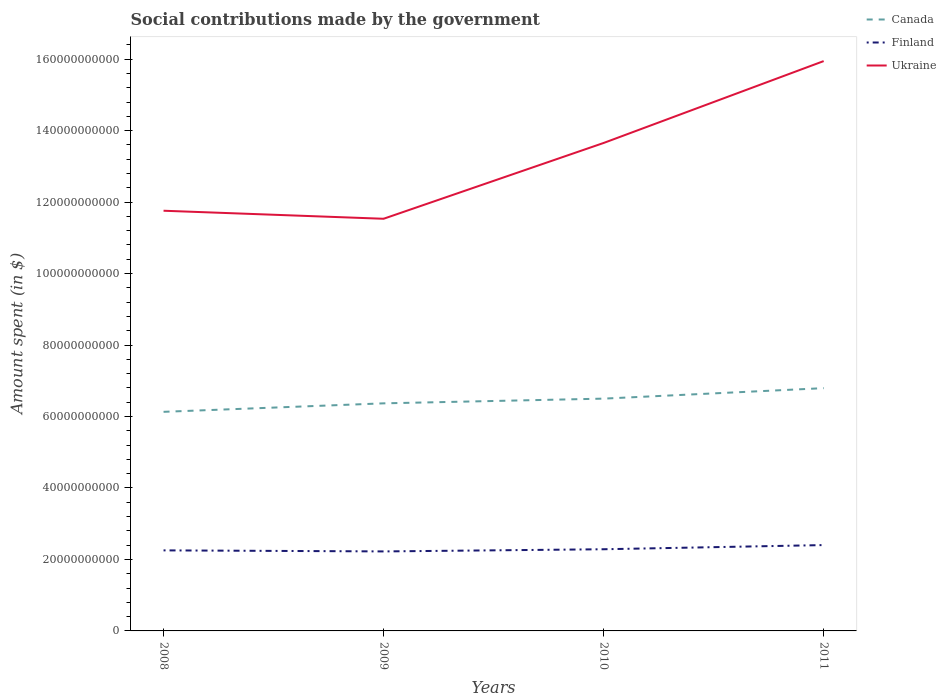How many different coloured lines are there?
Offer a terse response. 3. Does the line corresponding to Finland intersect with the line corresponding to Canada?
Provide a short and direct response. No. Across all years, what is the maximum amount spent on social contributions in Canada?
Make the answer very short. 6.13e+1. What is the total amount spent on social contributions in Finland in the graph?
Offer a very short reply. -3.15e+08. What is the difference between the highest and the second highest amount spent on social contributions in Finland?
Keep it short and to the point. 1.78e+09. How many legend labels are there?
Offer a terse response. 3. What is the title of the graph?
Your answer should be very brief. Social contributions made by the government. What is the label or title of the Y-axis?
Offer a terse response. Amount spent (in $). What is the Amount spent (in $) of Canada in 2008?
Provide a succinct answer. 6.13e+1. What is the Amount spent (in $) in Finland in 2008?
Provide a short and direct response. 2.25e+1. What is the Amount spent (in $) of Ukraine in 2008?
Your response must be concise. 1.18e+11. What is the Amount spent (in $) in Canada in 2009?
Provide a short and direct response. 6.37e+1. What is the Amount spent (in $) in Finland in 2009?
Give a very brief answer. 2.22e+1. What is the Amount spent (in $) in Ukraine in 2009?
Keep it short and to the point. 1.15e+11. What is the Amount spent (in $) in Canada in 2010?
Your answer should be very brief. 6.50e+1. What is the Amount spent (in $) of Finland in 2010?
Offer a terse response. 2.29e+1. What is the Amount spent (in $) of Ukraine in 2010?
Your answer should be very brief. 1.37e+11. What is the Amount spent (in $) in Canada in 2011?
Provide a succinct answer. 6.79e+1. What is the Amount spent (in $) of Finland in 2011?
Ensure brevity in your answer.  2.40e+1. What is the Amount spent (in $) of Ukraine in 2011?
Offer a very short reply. 1.59e+11. Across all years, what is the maximum Amount spent (in $) in Canada?
Give a very brief answer. 6.79e+1. Across all years, what is the maximum Amount spent (in $) of Finland?
Offer a terse response. 2.40e+1. Across all years, what is the maximum Amount spent (in $) of Ukraine?
Keep it short and to the point. 1.59e+11. Across all years, what is the minimum Amount spent (in $) in Canada?
Give a very brief answer. 6.13e+1. Across all years, what is the minimum Amount spent (in $) of Finland?
Your answer should be very brief. 2.22e+1. Across all years, what is the minimum Amount spent (in $) of Ukraine?
Ensure brevity in your answer.  1.15e+11. What is the total Amount spent (in $) in Canada in the graph?
Offer a terse response. 2.58e+11. What is the total Amount spent (in $) of Finland in the graph?
Provide a succinct answer. 9.17e+1. What is the total Amount spent (in $) of Ukraine in the graph?
Provide a succinct answer. 5.29e+11. What is the difference between the Amount spent (in $) in Canada in 2008 and that in 2009?
Your response must be concise. -2.37e+09. What is the difference between the Amount spent (in $) of Finland in 2008 and that in 2009?
Give a very brief answer. 2.94e+08. What is the difference between the Amount spent (in $) of Ukraine in 2008 and that in 2009?
Keep it short and to the point. 2.25e+09. What is the difference between the Amount spent (in $) of Canada in 2008 and that in 2010?
Your answer should be compact. -3.69e+09. What is the difference between the Amount spent (in $) in Finland in 2008 and that in 2010?
Your answer should be very brief. -3.15e+08. What is the difference between the Amount spent (in $) in Ukraine in 2008 and that in 2010?
Offer a terse response. -1.90e+1. What is the difference between the Amount spent (in $) of Canada in 2008 and that in 2011?
Keep it short and to the point. -6.63e+09. What is the difference between the Amount spent (in $) of Finland in 2008 and that in 2011?
Offer a terse response. -1.48e+09. What is the difference between the Amount spent (in $) of Ukraine in 2008 and that in 2011?
Keep it short and to the point. -4.19e+1. What is the difference between the Amount spent (in $) of Canada in 2009 and that in 2010?
Your answer should be compact. -1.32e+09. What is the difference between the Amount spent (in $) of Finland in 2009 and that in 2010?
Provide a succinct answer. -6.09e+08. What is the difference between the Amount spent (in $) in Ukraine in 2009 and that in 2010?
Provide a succinct answer. -2.12e+1. What is the difference between the Amount spent (in $) of Canada in 2009 and that in 2011?
Offer a terse response. -4.25e+09. What is the difference between the Amount spent (in $) in Finland in 2009 and that in 2011?
Your answer should be very brief. -1.78e+09. What is the difference between the Amount spent (in $) of Ukraine in 2009 and that in 2011?
Offer a terse response. -4.41e+1. What is the difference between the Amount spent (in $) in Canada in 2010 and that in 2011?
Your answer should be compact. -2.93e+09. What is the difference between the Amount spent (in $) in Finland in 2010 and that in 2011?
Your response must be concise. -1.17e+09. What is the difference between the Amount spent (in $) of Ukraine in 2010 and that in 2011?
Make the answer very short. -2.29e+1. What is the difference between the Amount spent (in $) in Canada in 2008 and the Amount spent (in $) in Finland in 2009?
Make the answer very short. 3.91e+1. What is the difference between the Amount spent (in $) of Canada in 2008 and the Amount spent (in $) of Ukraine in 2009?
Your response must be concise. -5.40e+1. What is the difference between the Amount spent (in $) of Finland in 2008 and the Amount spent (in $) of Ukraine in 2009?
Offer a very short reply. -9.28e+1. What is the difference between the Amount spent (in $) in Canada in 2008 and the Amount spent (in $) in Finland in 2010?
Make the answer very short. 3.85e+1. What is the difference between the Amount spent (in $) of Canada in 2008 and the Amount spent (in $) of Ukraine in 2010?
Keep it short and to the point. -7.52e+1. What is the difference between the Amount spent (in $) of Finland in 2008 and the Amount spent (in $) of Ukraine in 2010?
Offer a very short reply. -1.14e+11. What is the difference between the Amount spent (in $) in Canada in 2008 and the Amount spent (in $) in Finland in 2011?
Offer a very short reply. 3.73e+1. What is the difference between the Amount spent (in $) in Canada in 2008 and the Amount spent (in $) in Ukraine in 2011?
Provide a succinct answer. -9.81e+1. What is the difference between the Amount spent (in $) in Finland in 2008 and the Amount spent (in $) in Ukraine in 2011?
Your answer should be compact. -1.37e+11. What is the difference between the Amount spent (in $) in Canada in 2009 and the Amount spent (in $) in Finland in 2010?
Keep it short and to the point. 4.08e+1. What is the difference between the Amount spent (in $) of Canada in 2009 and the Amount spent (in $) of Ukraine in 2010?
Your response must be concise. -7.29e+1. What is the difference between the Amount spent (in $) in Finland in 2009 and the Amount spent (in $) in Ukraine in 2010?
Offer a terse response. -1.14e+11. What is the difference between the Amount spent (in $) in Canada in 2009 and the Amount spent (in $) in Finland in 2011?
Offer a very short reply. 3.97e+1. What is the difference between the Amount spent (in $) of Canada in 2009 and the Amount spent (in $) of Ukraine in 2011?
Provide a short and direct response. -9.58e+1. What is the difference between the Amount spent (in $) in Finland in 2009 and the Amount spent (in $) in Ukraine in 2011?
Ensure brevity in your answer.  -1.37e+11. What is the difference between the Amount spent (in $) of Canada in 2010 and the Amount spent (in $) of Finland in 2011?
Your answer should be very brief. 4.10e+1. What is the difference between the Amount spent (in $) in Canada in 2010 and the Amount spent (in $) in Ukraine in 2011?
Provide a succinct answer. -9.45e+1. What is the difference between the Amount spent (in $) of Finland in 2010 and the Amount spent (in $) of Ukraine in 2011?
Provide a succinct answer. -1.37e+11. What is the average Amount spent (in $) in Canada per year?
Offer a very short reply. 6.45e+1. What is the average Amount spent (in $) in Finland per year?
Offer a very short reply. 2.29e+1. What is the average Amount spent (in $) of Ukraine per year?
Make the answer very short. 1.32e+11. In the year 2008, what is the difference between the Amount spent (in $) of Canada and Amount spent (in $) of Finland?
Provide a succinct answer. 3.88e+1. In the year 2008, what is the difference between the Amount spent (in $) in Canada and Amount spent (in $) in Ukraine?
Keep it short and to the point. -5.63e+1. In the year 2008, what is the difference between the Amount spent (in $) in Finland and Amount spent (in $) in Ukraine?
Make the answer very short. -9.50e+1. In the year 2009, what is the difference between the Amount spent (in $) in Canada and Amount spent (in $) in Finland?
Ensure brevity in your answer.  4.14e+1. In the year 2009, what is the difference between the Amount spent (in $) in Canada and Amount spent (in $) in Ukraine?
Your response must be concise. -5.17e+1. In the year 2009, what is the difference between the Amount spent (in $) of Finland and Amount spent (in $) of Ukraine?
Your response must be concise. -9.31e+1. In the year 2010, what is the difference between the Amount spent (in $) of Canada and Amount spent (in $) of Finland?
Offer a very short reply. 4.21e+1. In the year 2010, what is the difference between the Amount spent (in $) of Canada and Amount spent (in $) of Ukraine?
Provide a succinct answer. -7.15e+1. In the year 2010, what is the difference between the Amount spent (in $) of Finland and Amount spent (in $) of Ukraine?
Offer a very short reply. -1.14e+11. In the year 2011, what is the difference between the Amount spent (in $) in Canada and Amount spent (in $) in Finland?
Offer a terse response. 4.39e+1. In the year 2011, what is the difference between the Amount spent (in $) of Canada and Amount spent (in $) of Ukraine?
Your answer should be compact. -9.15e+1. In the year 2011, what is the difference between the Amount spent (in $) in Finland and Amount spent (in $) in Ukraine?
Offer a terse response. -1.35e+11. What is the ratio of the Amount spent (in $) in Canada in 2008 to that in 2009?
Provide a short and direct response. 0.96. What is the ratio of the Amount spent (in $) in Finland in 2008 to that in 2009?
Provide a succinct answer. 1.01. What is the ratio of the Amount spent (in $) of Ukraine in 2008 to that in 2009?
Offer a terse response. 1.02. What is the ratio of the Amount spent (in $) of Canada in 2008 to that in 2010?
Offer a very short reply. 0.94. What is the ratio of the Amount spent (in $) in Finland in 2008 to that in 2010?
Keep it short and to the point. 0.99. What is the ratio of the Amount spent (in $) in Ukraine in 2008 to that in 2010?
Keep it short and to the point. 0.86. What is the ratio of the Amount spent (in $) in Canada in 2008 to that in 2011?
Ensure brevity in your answer.  0.9. What is the ratio of the Amount spent (in $) of Finland in 2008 to that in 2011?
Provide a short and direct response. 0.94. What is the ratio of the Amount spent (in $) of Ukraine in 2008 to that in 2011?
Offer a terse response. 0.74. What is the ratio of the Amount spent (in $) of Canada in 2009 to that in 2010?
Your answer should be very brief. 0.98. What is the ratio of the Amount spent (in $) of Finland in 2009 to that in 2010?
Keep it short and to the point. 0.97. What is the ratio of the Amount spent (in $) of Ukraine in 2009 to that in 2010?
Offer a very short reply. 0.84. What is the ratio of the Amount spent (in $) in Canada in 2009 to that in 2011?
Make the answer very short. 0.94. What is the ratio of the Amount spent (in $) in Finland in 2009 to that in 2011?
Ensure brevity in your answer.  0.93. What is the ratio of the Amount spent (in $) of Ukraine in 2009 to that in 2011?
Your response must be concise. 0.72. What is the ratio of the Amount spent (in $) of Canada in 2010 to that in 2011?
Keep it short and to the point. 0.96. What is the ratio of the Amount spent (in $) of Finland in 2010 to that in 2011?
Keep it short and to the point. 0.95. What is the ratio of the Amount spent (in $) of Ukraine in 2010 to that in 2011?
Provide a short and direct response. 0.86. What is the difference between the highest and the second highest Amount spent (in $) in Canada?
Your answer should be very brief. 2.93e+09. What is the difference between the highest and the second highest Amount spent (in $) of Finland?
Offer a very short reply. 1.17e+09. What is the difference between the highest and the second highest Amount spent (in $) of Ukraine?
Your answer should be compact. 2.29e+1. What is the difference between the highest and the lowest Amount spent (in $) of Canada?
Your answer should be very brief. 6.63e+09. What is the difference between the highest and the lowest Amount spent (in $) in Finland?
Make the answer very short. 1.78e+09. What is the difference between the highest and the lowest Amount spent (in $) in Ukraine?
Your answer should be compact. 4.41e+1. 